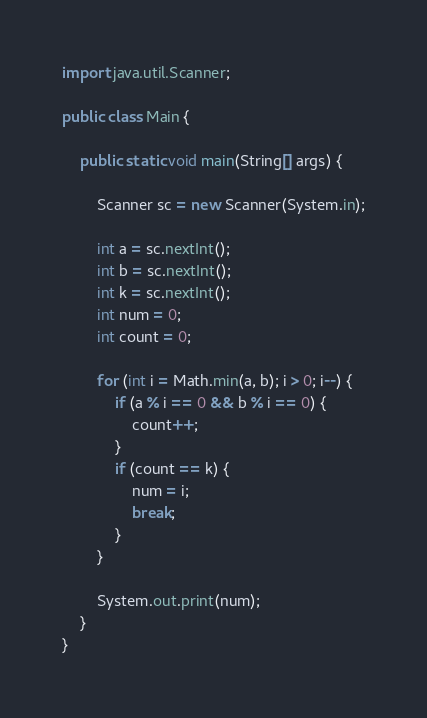Convert code to text. <code><loc_0><loc_0><loc_500><loc_500><_Java_>import java.util.Scanner;

public class Main {

	public static void main(String[] args) {

		Scanner sc = new Scanner(System.in);

		int a = sc.nextInt();
		int b = sc.nextInt();
		int k = sc.nextInt();
		int num = 0;
		int count = 0;

		for (int i = Math.min(a, b); i > 0; i--) {
			if (a % i == 0 && b % i == 0) {
				count++;
			}
			if (count == k) {
				num = i;
				break;
			}
		}

		System.out.print(num);
	}
}</code> 